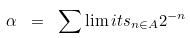Convert formula to latex. <formula><loc_0><loc_0><loc_500><loc_500>\alpha \ = \ \sum \lim i t s _ { n \in A } 2 ^ { - n }</formula> 